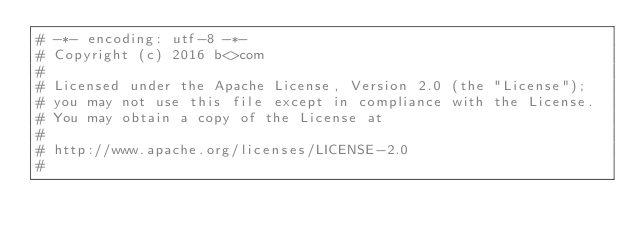Convert code to text. <code><loc_0><loc_0><loc_500><loc_500><_Python_># -*- encoding: utf-8 -*-
# Copyright (c) 2016 b<>com
#
# Licensed under the Apache License, Version 2.0 (the "License");
# you may not use this file except in compliance with the License.
# You may obtain a copy of the License at
#
# http://www.apache.org/licenses/LICENSE-2.0
#</code> 